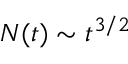<formula> <loc_0><loc_0><loc_500><loc_500>N ( t ) \sim t ^ { 3 / 2 }</formula> 